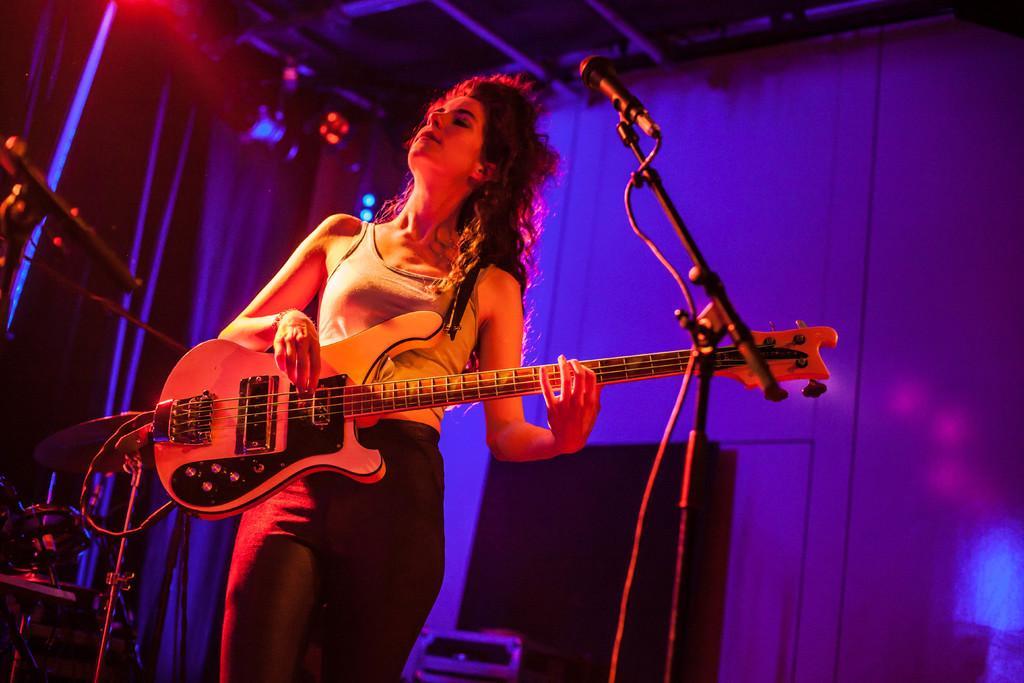How would you summarize this image in a sentence or two? In this picture i could see a woman holding a guitar in her hands and standing in front of the mics giving a stage performance. In the background i could see the purple curtain and a wall. 